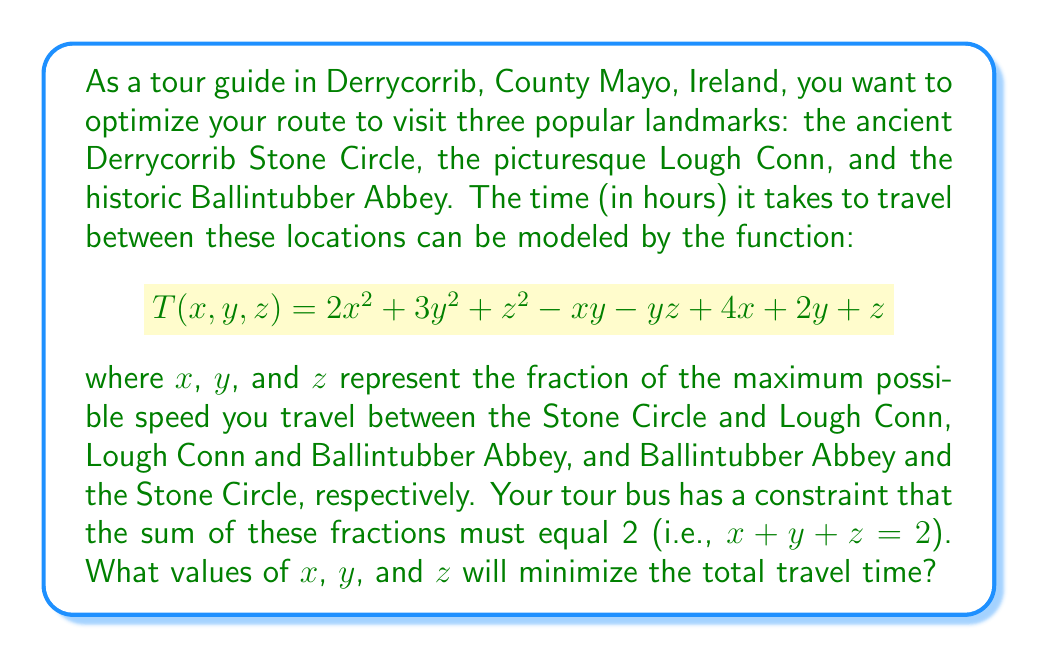Teach me how to tackle this problem. To solve this constrained optimization problem, we'll use the method of Lagrange multipliers:

1) First, let's define our Lagrangian function:
   $$L(x, y, z, \lambda) = 2x^2 + 3y^2 + z^2 - xy - yz + 4x + 2y + z + \lambda(x + y + z - 2)$$

2) Now, we'll take partial derivatives with respect to x, y, z, and λ:
   $$\frac{\partial L}{\partial x} = 4x - y + 4 + \lambda = 0$$
   $$\frac{\partial L}{\partial y} = 6y - x - z + 2 + \lambda = 0$$
   $$\frac{\partial L}{\partial z} = 2z - y + 1 + \lambda = 0$$
   $$\frac{\partial L}{\partial \lambda} = x + y + z - 2 = 0$$

3) From the first equation:
   $$x = \frac{y - 4 - \lambda}{4}$$

4) From the third equation:
   $$z = \frac{y - 1 - \lambda}{2}$$

5) Substituting these into the constraint equation:
   $$\frac{y - 4 - \lambda}{4} + y + \frac{y - 1 - \lambda}{2} - 2 = 0$$

6) Simplifying:
   $$3y - 5 - \frac{3\lambda}{2} = 0$$
   $$y = \frac{5 + \frac{3\lambda}{2}}{3}$$

7) Substituting this back into the second equation:
   $$6(\frac{5 + \frac{3\lambda}{2}}{3}) - (\frac{5 + \frac{3\lambda}{2}}{3} - 4 - \lambda) - (\frac{5 + \frac{3\lambda}{2}}{3} - 1 - \lambda) + 2 + \lambda = 0$$

8) Solving this equation for λ gives:
   $$\lambda = -2$$

9) Now we can solve for x, y, and z:
   $$y = \frac{5 + \frac{3(-2)}{2}}{3} = 1$$
   $$x = \frac{1 - 4 - (-2)}{4} = \frac{-1}{4}$$
   $$z = \frac{1 - 1 - (-2)}{2} = 1$$

10) However, since x represents a fraction of speed, it cannot be negative. This means our solution lies on the boundary of our constraint. The closest valid point is (0, 1, 1).
Answer: The optimal values are $x = 0$, $y = 1$, and $z = 1$. This means you should travel at maximum speed between Lough Conn and Ballintubber Abbey, and between Ballintubber Abbey and the Stone Circle, while minimizing travel between the Stone Circle and Lough Conn. 